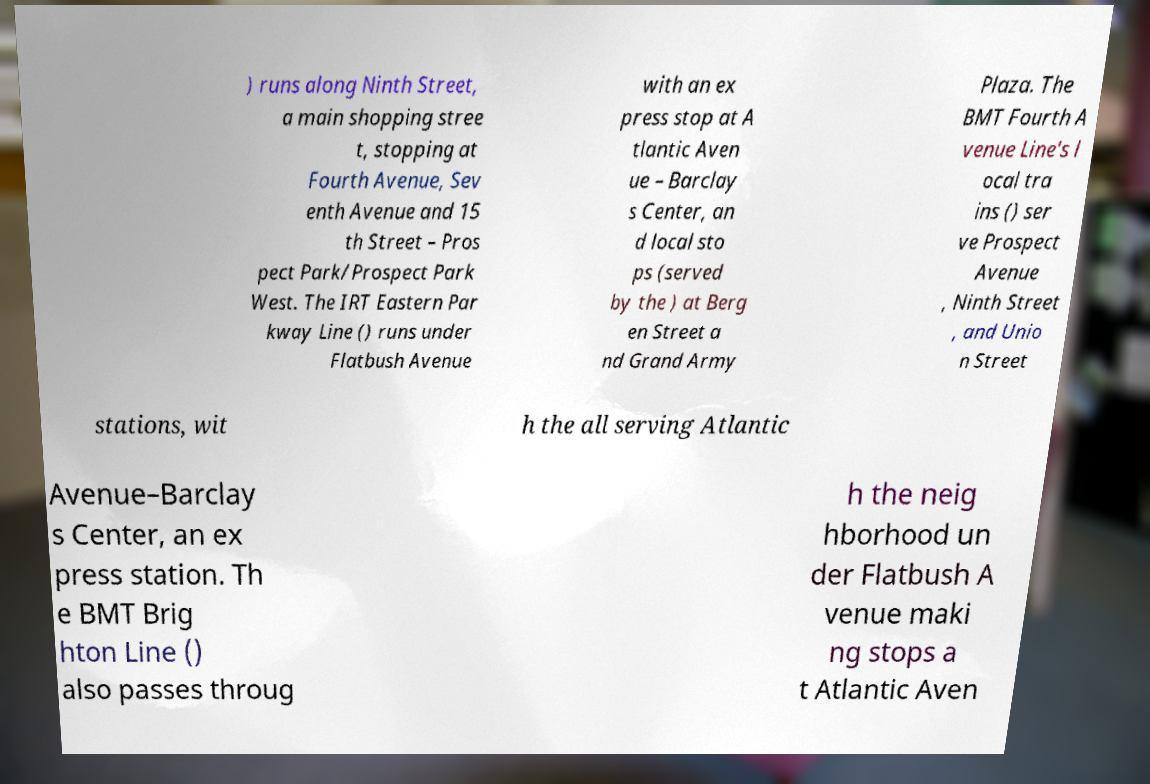Can you read and provide the text displayed in the image?This photo seems to have some interesting text. Can you extract and type it out for me? ) runs along Ninth Street, a main shopping stree t, stopping at Fourth Avenue, Sev enth Avenue and 15 th Street – Pros pect Park/Prospect Park West. The IRT Eastern Par kway Line () runs under Flatbush Avenue with an ex press stop at A tlantic Aven ue – Barclay s Center, an d local sto ps (served by the ) at Berg en Street a nd Grand Army Plaza. The BMT Fourth A venue Line's l ocal tra ins () ser ve Prospect Avenue , Ninth Street , and Unio n Street stations, wit h the all serving Atlantic Avenue–Barclay s Center, an ex press station. Th e BMT Brig hton Line () also passes throug h the neig hborhood un der Flatbush A venue maki ng stops a t Atlantic Aven 